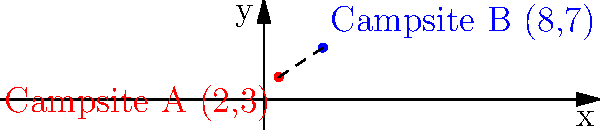During a family camping trip in Hobbs State Park, you set up two campsites: Campsite A at coordinates (2,3) and Campsite B at coordinates (8,7). Using the distance formula, calculate the distance between these two campsites. Round your answer to the nearest tenth of a mile. To solve this problem, we'll use the distance formula:

$d = \sqrt{(x_2-x_1)^2 + (y_2-y_1)^2}$

Where $(x_1,y_1)$ is Campsite A (2,3) and $(x_2,y_2)$ is Campsite B (8,7).

Step 1: Substitute the coordinate values into the formula:
$d = \sqrt{(8-2)^2 + (7-3)^2}$

Step 2: Simplify inside the parentheses:
$d = \sqrt{6^2 + 4^2}$

Step 3: Calculate the squares:
$d = \sqrt{36 + 16}$

Step 4: Add under the square root:
$d = \sqrt{52}$

Step 5: Simplify the square root:
$d = \sqrt{52} \approx 7.211102551$

Step 6: Round to the nearest tenth:
$d \approx 7.2$ miles
Answer: 7.2 miles 